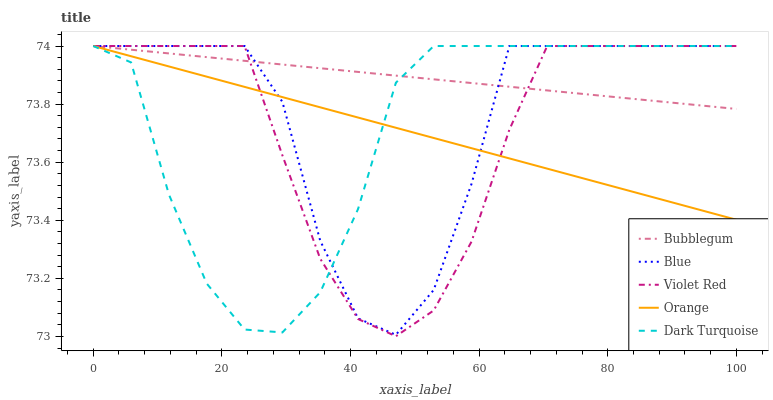Does Orange have the minimum area under the curve?
Answer yes or no. Yes. Does Bubblegum have the maximum area under the curve?
Answer yes or no. Yes. Does Violet Red have the minimum area under the curve?
Answer yes or no. No. Does Violet Red have the maximum area under the curve?
Answer yes or no. No. Is Orange the smoothest?
Answer yes or no. Yes. Is Blue the roughest?
Answer yes or no. Yes. Is Violet Red the smoothest?
Answer yes or no. No. Is Violet Red the roughest?
Answer yes or no. No. Does Violet Red have the lowest value?
Answer yes or no. Yes. Does Orange have the lowest value?
Answer yes or no. No. Does Dark Turquoise have the highest value?
Answer yes or no. Yes. Does Bubblegum intersect Orange?
Answer yes or no. Yes. Is Bubblegum less than Orange?
Answer yes or no. No. Is Bubblegum greater than Orange?
Answer yes or no. No. 